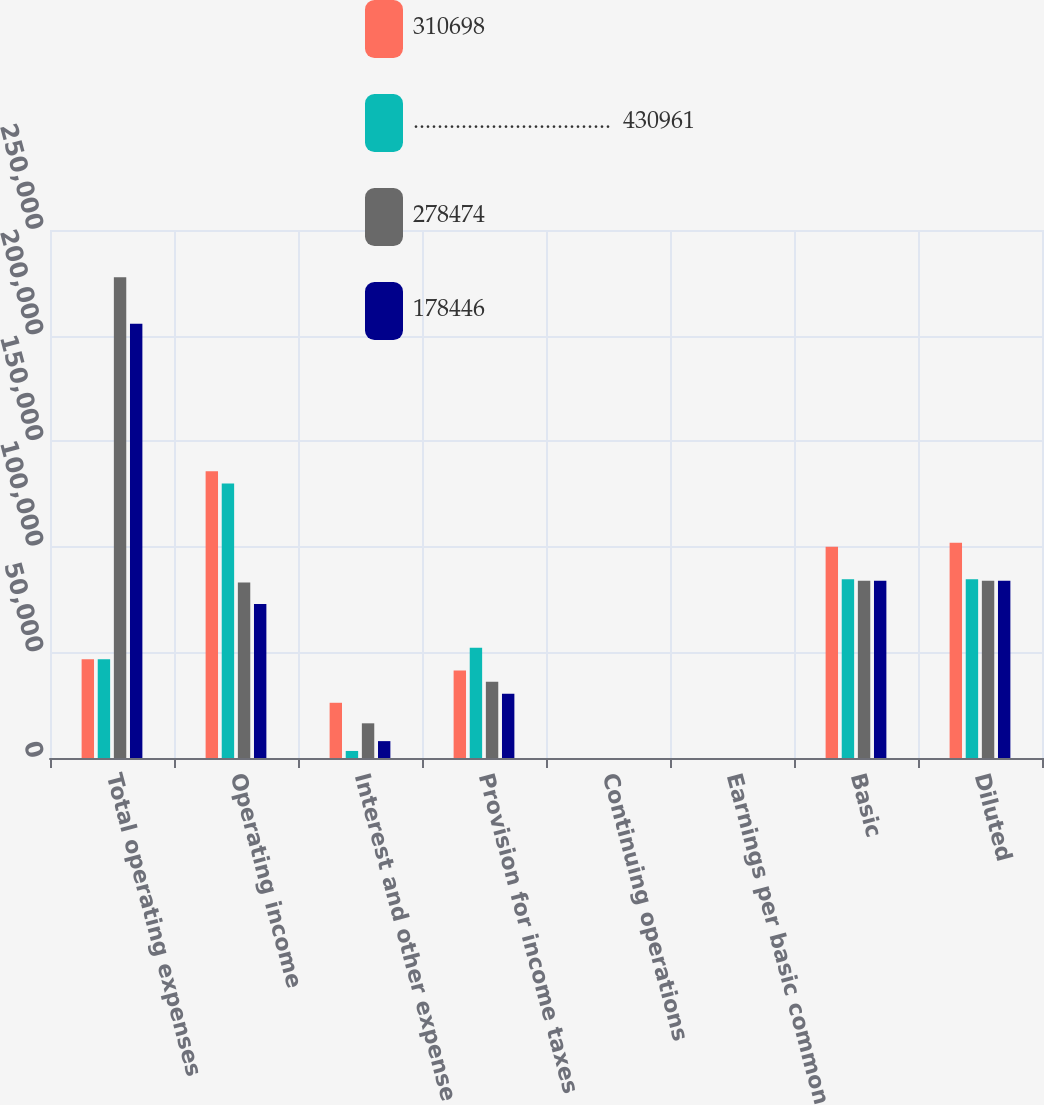<chart> <loc_0><loc_0><loc_500><loc_500><stacked_bar_chart><ecel><fcel>Total operating expenses<fcel>Operating income<fcel>Interest and other expense<fcel>Provision for income taxes<fcel>Continuing operations<fcel>Earnings per basic common<fcel>Basic<fcel>Diluted<nl><fcel>310698<fcel>46778<fcel>135790<fcel>26147<fcel>41375<fcel>0.68<fcel>0.68<fcel>100037<fcel>101904<nl><fcel>.................................  430961<fcel>46778<fcel>129959<fcel>3333<fcel>52181<fcel>0.96<fcel>0.96<fcel>84608<fcel>84624<nl><fcel>278474<fcel>227649<fcel>83049<fcel>16420<fcel>36097<fcel>0.76<fcel>0.85<fcel>83900<fcel>83900<nl><fcel>178446<fcel>205567<fcel>72907<fcel>7990<fcel>30449<fcel>0.6<fcel>0.65<fcel>83900<fcel>83900<nl></chart> 